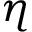Convert formula to latex. <formula><loc_0><loc_0><loc_500><loc_500>\eta</formula> 